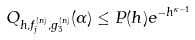Convert formula to latex. <formula><loc_0><loc_0><loc_500><loc_500>Q _ { h , f _ { j } ^ { ( n ) } , g _ { 3 } ^ { ( n ) } } ( \alpha ) \leq P ( h ) e ^ { - h ^ { \kappa - 1 } }</formula> 